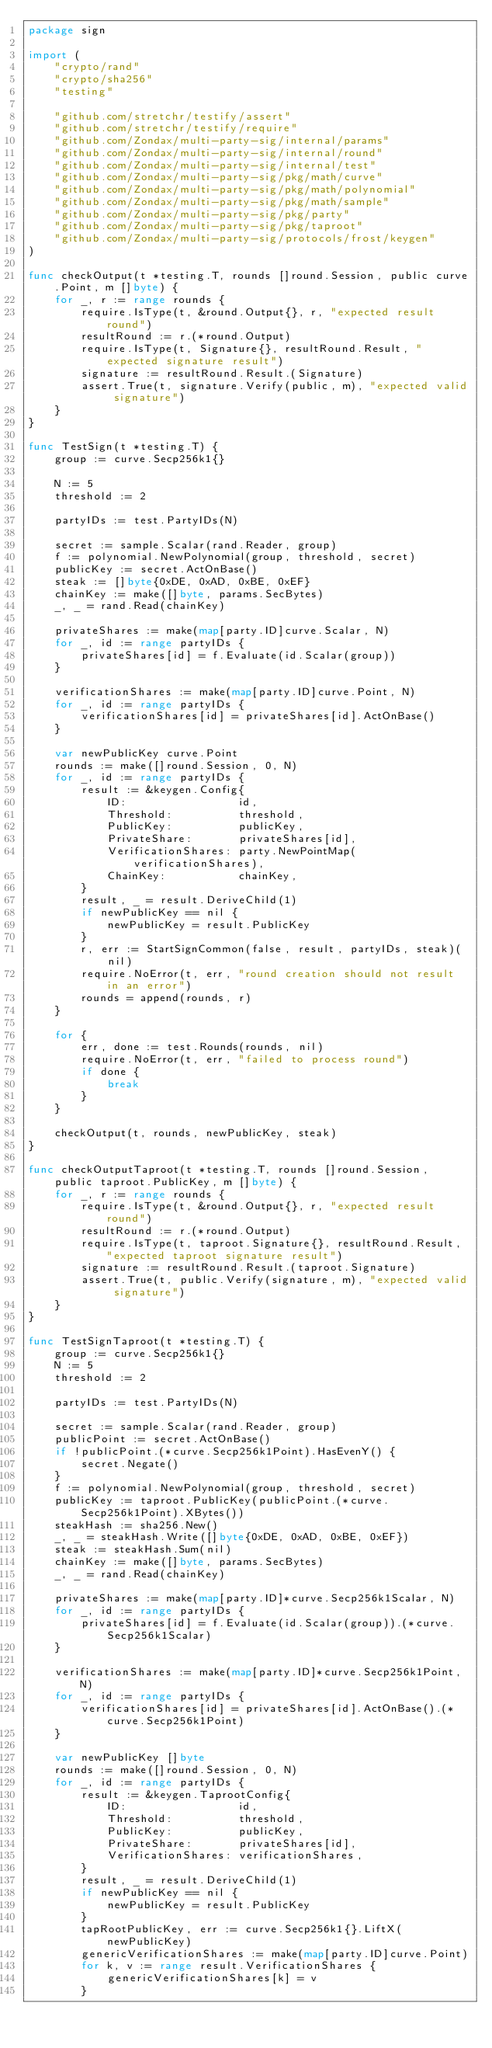<code> <loc_0><loc_0><loc_500><loc_500><_Go_>package sign

import (
	"crypto/rand"
	"crypto/sha256"
	"testing"

	"github.com/stretchr/testify/assert"
	"github.com/stretchr/testify/require"
	"github.com/Zondax/multi-party-sig/internal/params"
	"github.com/Zondax/multi-party-sig/internal/round"
	"github.com/Zondax/multi-party-sig/internal/test"
	"github.com/Zondax/multi-party-sig/pkg/math/curve"
	"github.com/Zondax/multi-party-sig/pkg/math/polynomial"
	"github.com/Zondax/multi-party-sig/pkg/math/sample"
	"github.com/Zondax/multi-party-sig/pkg/party"
	"github.com/Zondax/multi-party-sig/pkg/taproot"
	"github.com/Zondax/multi-party-sig/protocols/frost/keygen"
)

func checkOutput(t *testing.T, rounds []round.Session, public curve.Point, m []byte) {
	for _, r := range rounds {
		require.IsType(t, &round.Output{}, r, "expected result round")
		resultRound := r.(*round.Output)
		require.IsType(t, Signature{}, resultRound.Result, "expected signature result")
		signature := resultRound.Result.(Signature)
		assert.True(t, signature.Verify(public, m), "expected valid signature")
	}
}

func TestSign(t *testing.T) {
	group := curve.Secp256k1{}

	N := 5
	threshold := 2

	partyIDs := test.PartyIDs(N)

	secret := sample.Scalar(rand.Reader, group)
	f := polynomial.NewPolynomial(group, threshold, secret)
	publicKey := secret.ActOnBase()
	steak := []byte{0xDE, 0xAD, 0xBE, 0xEF}
	chainKey := make([]byte, params.SecBytes)
	_, _ = rand.Read(chainKey)

	privateShares := make(map[party.ID]curve.Scalar, N)
	for _, id := range partyIDs {
		privateShares[id] = f.Evaluate(id.Scalar(group))
	}

	verificationShares := make(map[party.ID]curve.Point, N)
	for _, id := range partyIDs {
		verificationShares[id] = privateShares[id].ActOnBase()
	}

	var newPublicKey curve.Point
	rounds := make([]round.Session, 0, N)
	for _, id := range partyIDs {
		result := &keygen.Config{
			ID:                 id,
			Threshold:          threshold,
			PublicKey:          publicKey,
			PrivateShare:       privateShares[id],
			VerificationShares: party.NewPointMap(verificationShares),
			ChainKey:           chainKey,
		}
		result, _ = result.DeriveChild(1)
		if newPublicKey == nil {
			newPublicKey = result.PublicKey
		}
		r, err := StartSignCommon(false, result, partyIDs, steak)(nil)
		require.NoError(t, err, "round creation should not result in an error")
		rounds = append(rounds, r)
	}

	for {
		err, done := test.Rounds(rounds, nil)
		require.NoError(t, err, "failed to process round")
		if done {
			break
		}
	}

	checkOutput(t, rounds, newPublicKey, steak)
}

func checkOutputTaproot(t *testing.T, rounds []round.Session, public taproot.PublicKey, m []byte) {
	for _, r := range rounds {
		require.IsType(t, &round.Output{}, r, "expected result round")
		resultRound := r.(*round.Output)
		require.IsType(t, taproot.Signature{}, resultRound.Result, "expected taproot signature result")
		signature := resultRound.Result.(taproot.Signature)
		assert.True(t, public.Verify(signature, m), "expected valid signature")
	}
}

func TestSignTaproot(t *testing.T) {
	group := curve.Secp256k1{}
	N := 5
	threshold := 2

	partyIDs := test.PartyIDs(N)

	secret := sample.Scalar(rand.Reader, group)
	publicPoint := secret.ActOnBase()
	if !publicPoint.(*curve.Secp256k1Point).HasEvenY() {
		secret.Negate()
	}
	f := polynomial.NewPolynomial(group, threshold, secret)
	publicKey := taproot.PublicKey(publicPoint.(*curve.Secp256k1Point).XBytes())
	steakHash := sha256.New()
	_, _ = steakHash.Write([]byte{0xDE, 0xAD, 0xBE, 0xEF})
	steak := steakHash.Sum(nil)
	chainKey := make([]byte, params.SecBytes)
	_, _ = rand.Read(chainKey)

	privateShares := make(map[party.ID]*curve.Secp256k1Scalar, N)
	for _, id := range partyIDs {
		privateShares[id] = f.Evaluate(id.Scalar(group)).(*curve.Secp256k1Scalar)
	}

	verificationShares := make(map[party.ID]*curve.Secp256k1Point, N)
	for _, id := range partyIDs {
		verificationShares[id] = privateShares[id].ActOnBase().(*curve.Secp256k1Point)
	}

	var newPublicKey []byte
	rounds := make([]round.Session, 0, N)
	for _, id := range partyIDs {
		result := &keygen.TaprootConfig{
			ID:                 id,
			Threshold:          threshold,
			PublicKey:          publicKey,
			PrivateShare:       privateShares[id],
			VerificationShares: verificationShares,
		}
		result, _ = result.DeriveChild(1)
		if newPublicKey == nil {
			newPublicKey = result.PublicKey
		}
		tapRootPublicKey, err := curve.Secp256k1{}.LiftX(newPublicKey)
		genericVerificationShares := make(map[party.ID]curve.Point)
		for k, v := range result.VerificationShares {
			genericVerificationShares[k] = v
		}</code> 